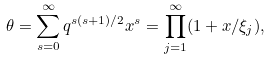<formula> <loc_0><loc_0><loc_500><loc_500>\theta = \sum _ { s = 0 } ^ { \infty } q ^ { s ( s + 1 ) / 2 } x ^ { s } = \prod _ { j = 1 } ^ { \infty } ( 1 + x / \xi _ { j } ) ,</formula> 